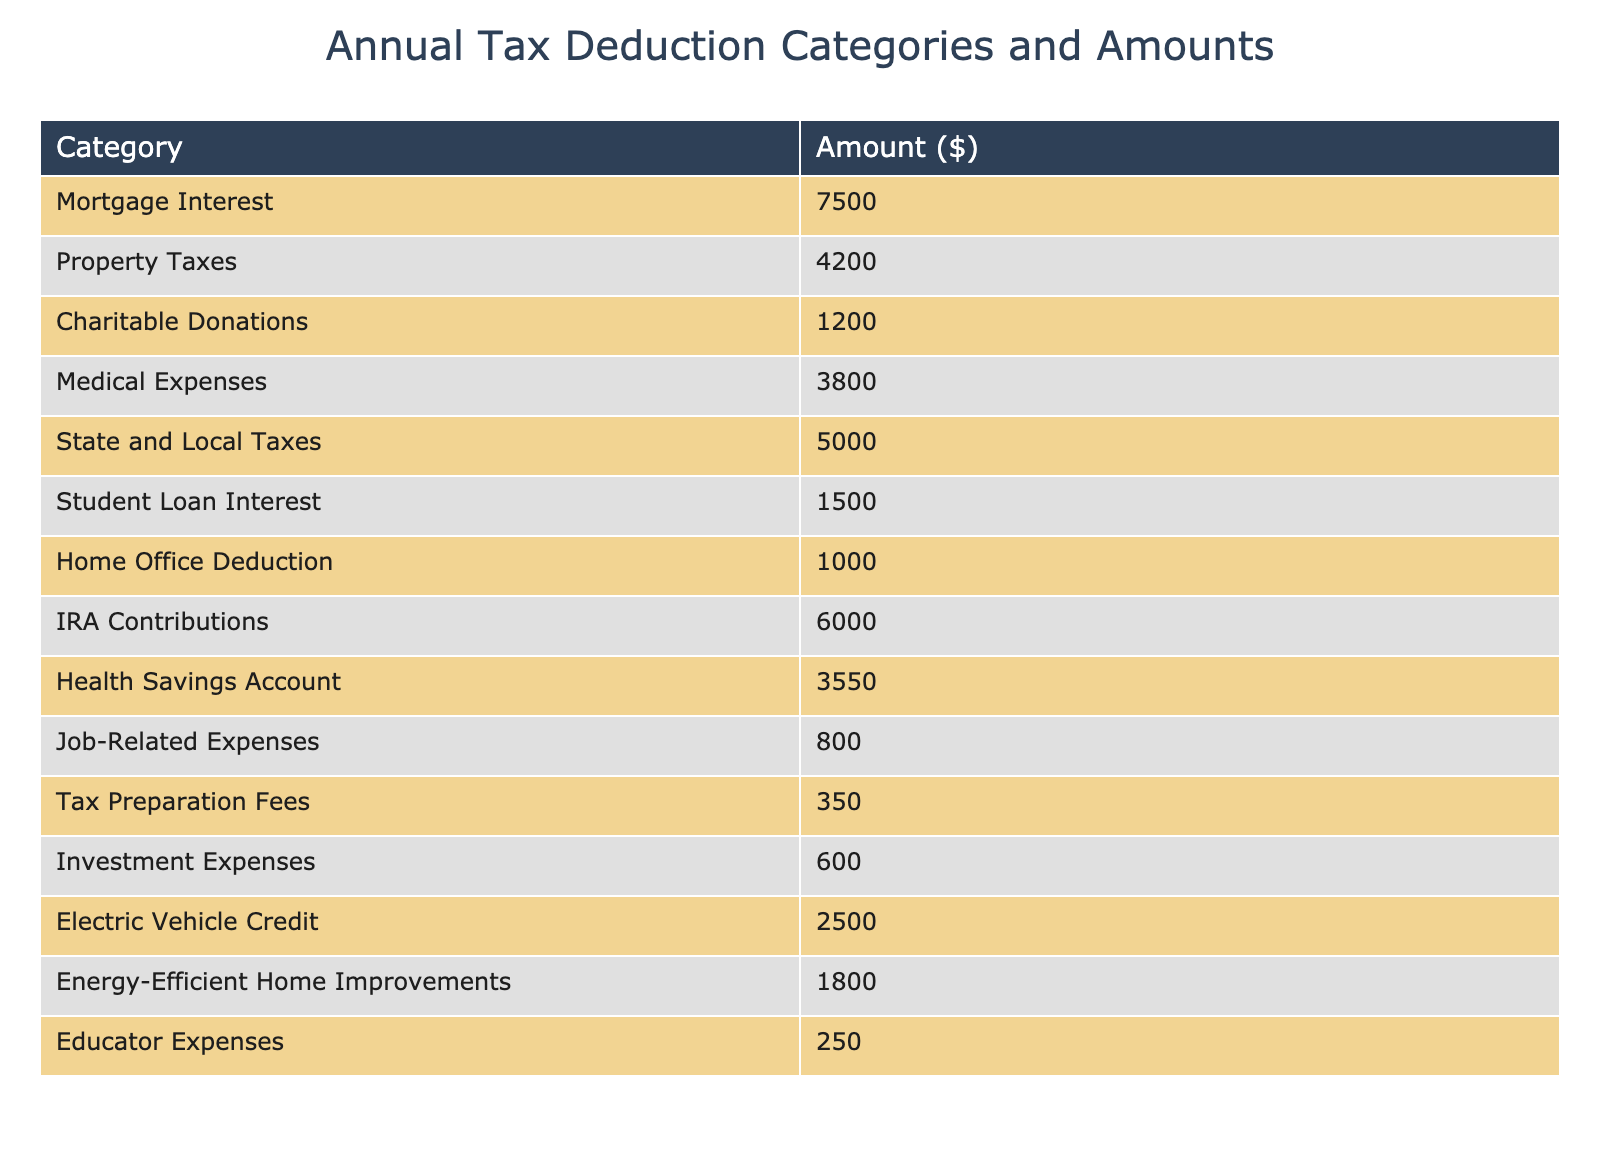What is the amount for Mortgage Interest? The table shows the category 'Mortgage Interest' with an amount of $7,500 listed next to it.
Answer: 7500 What is the total amount for Charitable Donations and Medical Expenses combined? The amount for Charitable Donations is $1,200, and the amount for Medical Expenses is $3,800. Adding these together gives $1,200 + $3,800 = $5,000.
Answer: 5000 Are there any tax deductions with an amount greater than $4,000? Looking through the table, both Mortgage Interest ($7,500) and State and Local Taxes ($5,000) have amounts exceeding $4,000. Therefore, the answer is yes.
Answer: Yes What is the highest tax deduction amount in the table? The amounts in the table are $7,500 for Mortgage Interest and $5,000 for State and Local Taxes. Comparing these, the highest is $7,500.
Answer: 7500 What is the average amount of all tax deductions listed? First, we sum all amounts: $7,500 + $4,200 + $1,200 + $3,800 + $5,000 + $1,500 + $1,000 + $6,000 + $3,550 + $800 + $350 + $600 + $2,500 + $1,800 + $250 = $39,450. There are 15 categories, so we divide total by 15: $39,450 / 15 = $2,630.
Answer: 2630 Is the total amount of Student Loan Interest more than $2,000? The table states the amount for Student Loan Interest is $1,500, which is less than $2,000. Thus, the answer is no.
Answer: No What percentage of the total deductions does Home Office Deduction represent? The amount for Home Office Deduction is $1,000. We previously calculated the total deductions as $39,450. To find the percentage, we divide $1,000 by $39,450 and multiply by 100: ($1,000 / $39,450) * 100 ≈ 2.54%.
Answer: 2.54% Which deduction category has the smallest amount and what is that amount? Scanning the table shows the category 'Educator Expenses' with an amount of $250, which is the smallest compared to all other categories.
Answer: 250 What is the difference between the amounts of State and Local Taxes and Property Taxes? The amount for State and Local Taxes is $5,000 and Property Taxes is $4,200. The difference is $5,000 - $4,200 = $800.
Answer: 800 